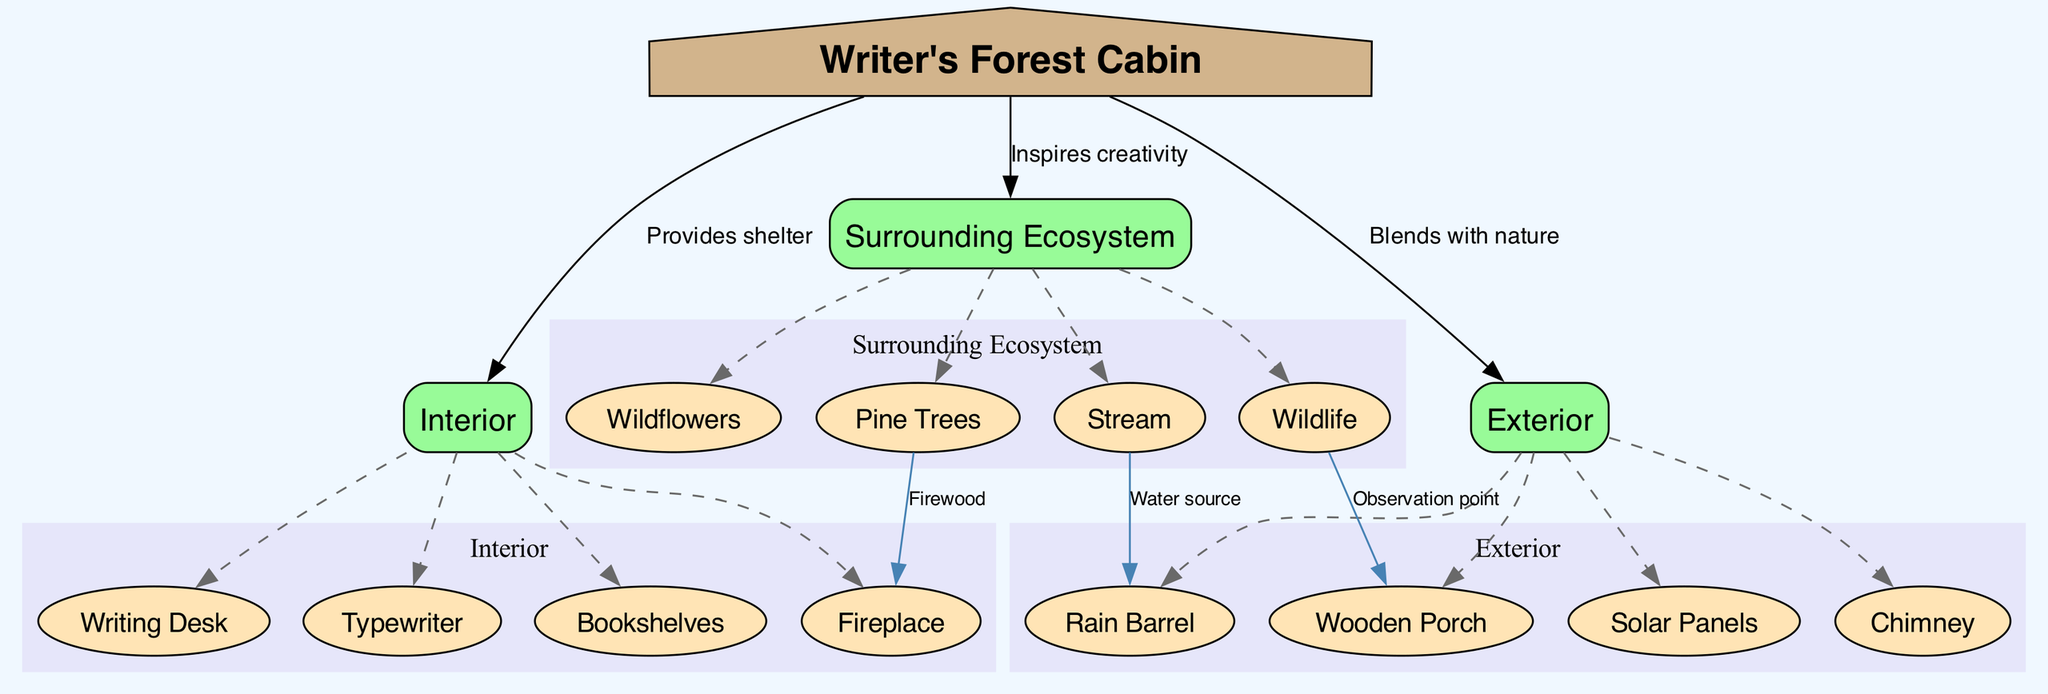What is the center node of the diagram? The center node is explicitly labeled in the diagram as "Writer's Forest Cabin."
Answer: Writer's Forest Cabin How many main nodes are there? The diagram lists three main nodes: Interior, Exterior, and Surrounding Ecosystem, which can be counted directly.
Answer: 3 What is the relationship between the Writer's Forest Cabin and the Surrounding Ecosystem? The connection from the Writer's Forest Cabin to the Surrounding Ecosystem is labeled "Inspires creativity," indicating its influence.
Answer: Inspires creativity Which sub-node is directly connected to the Rain Barrel? The diagram shows that the Rain Barrel has a connection labeled "Water source" specifically to the Stream.
Answer: Stream Which sub-node serves as an observation point? The connection from Wildlife to Wooden Porch indicates that the Wooden Porch is the designated observation point for observing the surrounding wildlife.
Answer: Wooden Porch How many sub-nodes are there in the Interior? The Interior has four sub-nodes: Writing Desk, Typewriter, Bookshelves, and Fireplace, which can be counted directly.
Answer: 4 What type of trees are present in the Surrounding Ecosystem? The diagram specifies that Pine Trees are included in the Surrounding Ecosystem as a distinct sub-node.
Answer: Pine Trees How does the Writer's Forest Cabin blend with nature? The relationship noted in the diagram states that the Writer's Forest Cabin "Blends with nature," indicating its harmony with the surrounding environment.
Answer: Blends with nature What is the connection between Pine Trees and the Fireplace? The diagram shows a direct link that indicates "Firewood" as the connection, meaning Pine Trees provide firewood for the Fireplace.
Answer: Firewood What color represents the main nodes in the diagram? The main nodes are colored #98FB98, a light green hue, which is specified in the diagram for visual representation.
Answer: #98FB98 